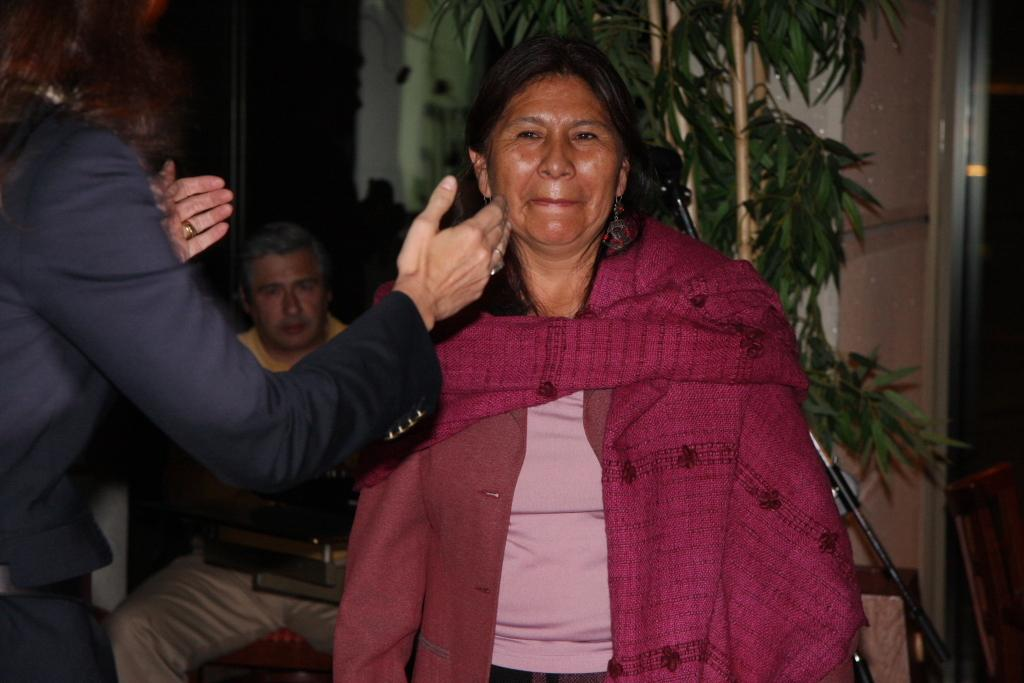What are the people in the image doing? The people in the image are standing. Is there anyone sitting in the image? Yes, there is a person sitting on a chair in the image. What type of vegetation is present in the image? There is a plant in the image. What can be seen on the right side of the image? There are objects on the right side of the image. What instrument is being played by the person sitting on the chair in the image? There is no instrument visible in the image, and the person sitting on the chair is not playing any instrument. 